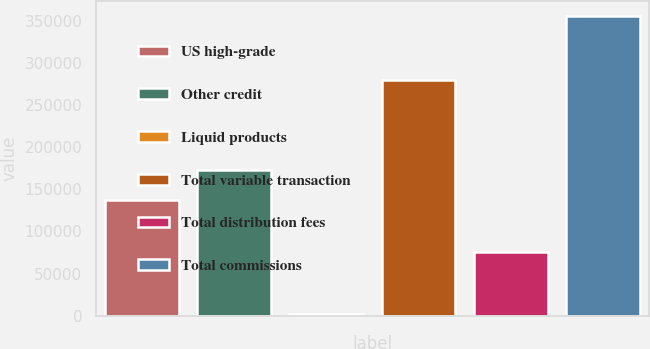Convert chart to OTSL. <chart><loc_0><loc_0><loc_500><loc_500><bar_chart><fcel>US high-grade<fcel>Other credit<fcel>Liquid products<fcel>Total variable transaction<fcel>Total distribution fees<fcel>Total commissions<nl><fcel>137034<fcel>172334<fcel>2277<fcel>279803<fcel>75479<fcel>355282<nl></chart> 